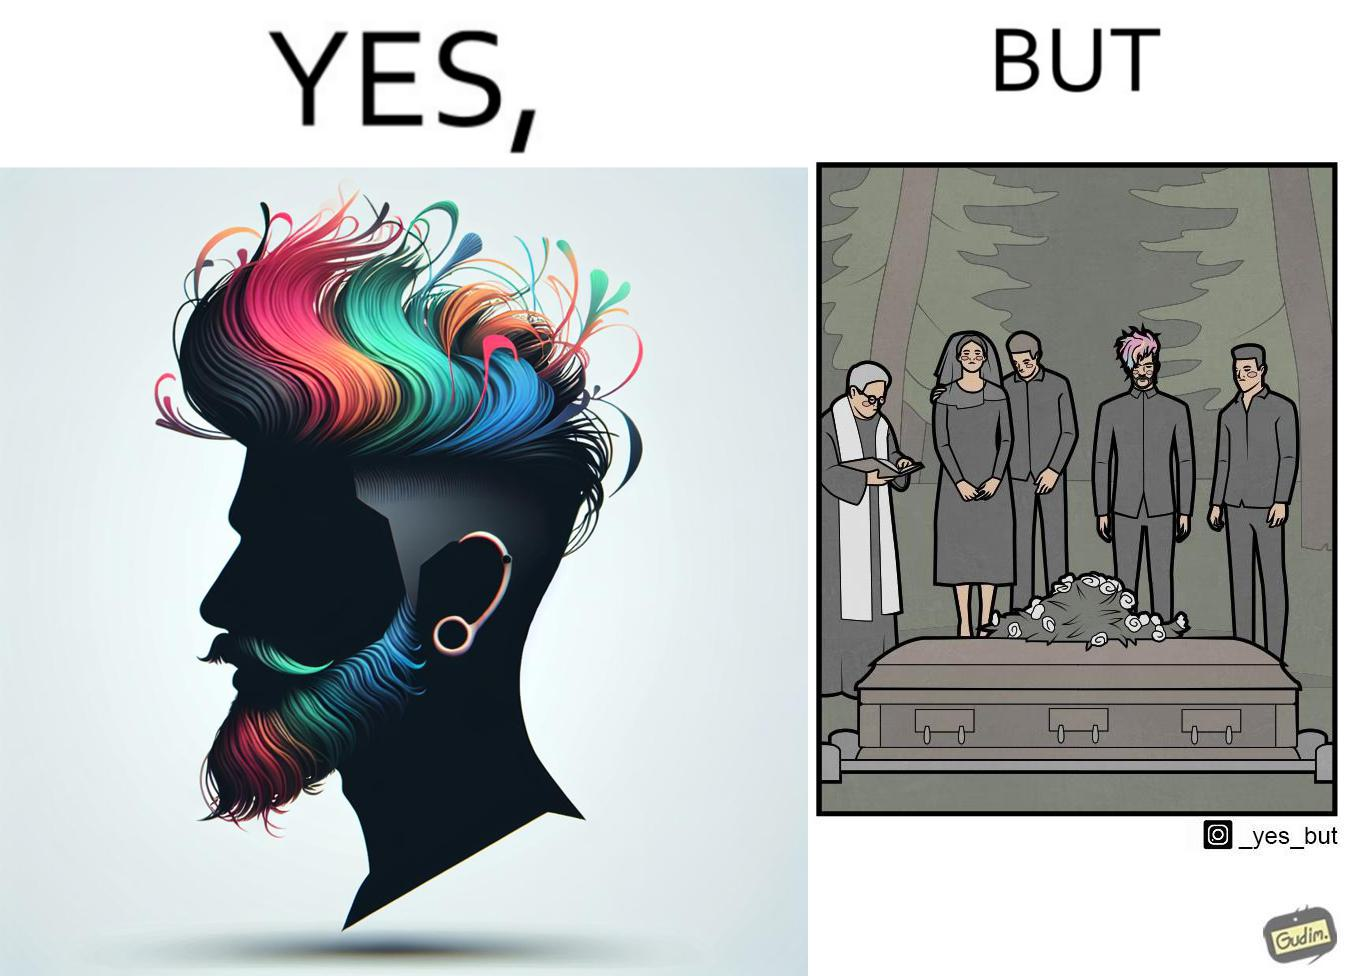Describe the content of this image. The image is ironic, because in the second image it is shown that a group of people is attending someone's death ceremony but one of them is shown as wrongly dressed for that place in first image, his visual appearances doesn't shows his feeling of mourning 